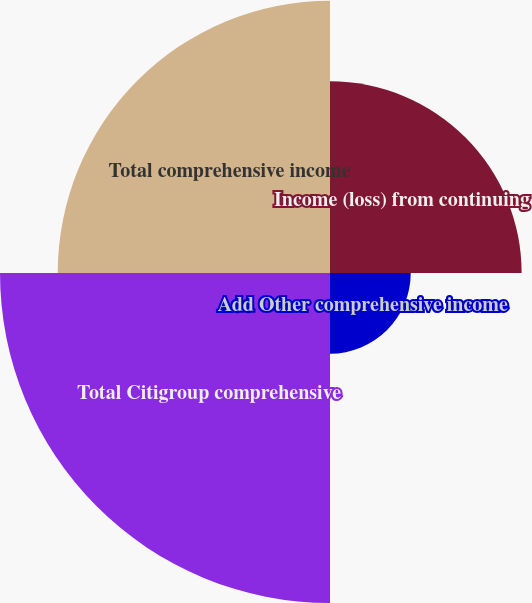<chart> <loc_0><loc_0><loc_500><loc_500><pie_chart><fcel>Income (loss) from continuing<fcel>Add Other comprehensive income<fcel>Total Citigroup comprehensive<fcel>Total comprehensive income<nl><fcel>21.91%<fcel>9.23%<fcel>37.73%<fcel>31.13%<nl></chart> 